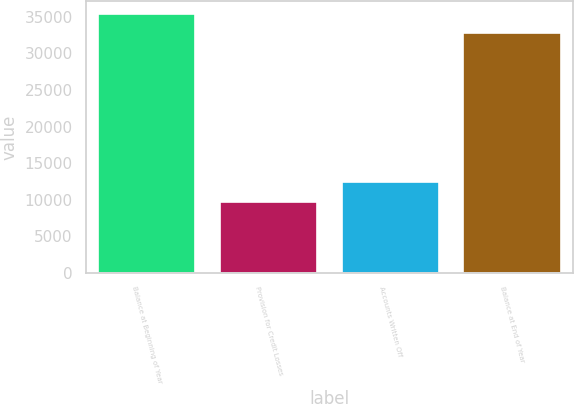Convert chart. <chart><loc_0><loc_0><loc_500><loc_500><bar_chart><fcel>Balance at Beginning of Year<fcel>Provision for Credit Losses<fcel>Accounts Written Off<fcel>Balance at End of Year<nl><fcel>35367.9<fcel>9730<fcel>12473<fcel>32817<nl></chart> 